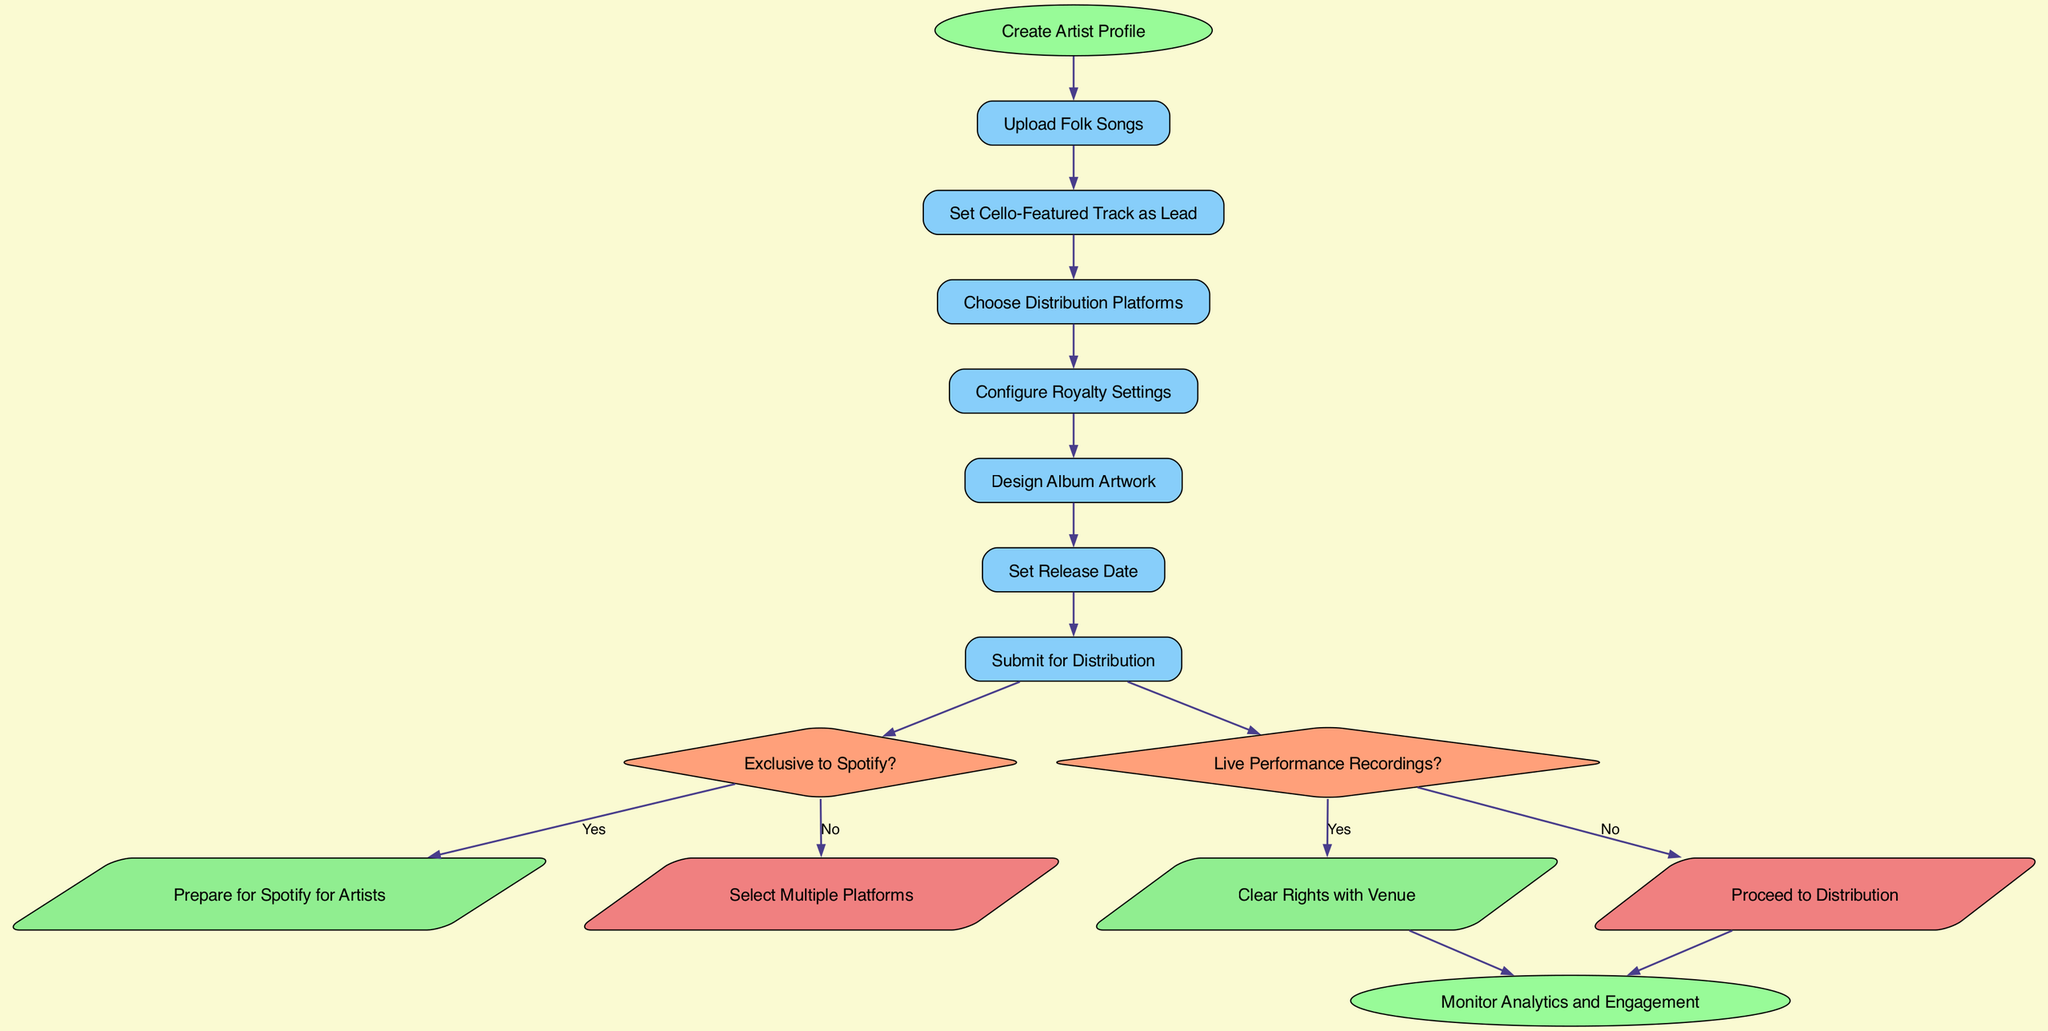What's the starting node of the flowchart? The starting node is indicated at the top of the flowchart and is labeled "Create Artist Profile."
Answer: Create Artist Profile How many nodes are there in total? Count all the nodes, including the start and end nodes. The nodes listed are: Create Artist Profile, Upload Folk Songs, Set Cello-Featured Track as Lead, Choose Distribution Platforms, Configure Royalty Settings, Design Album Artwork, Set Release Date, Submit for Distribution, and Monitor Analytics and Engagement, which totals 10 nodes.
Answer: 10 What are the actions performed after "Submit for Distribution"? After "Submit for Distribution," the flowchart leads to a decision node asking if there are live performance recordings.
Answer: Clear Rights with Venue or Proceed to Distribution What happens if you select "Exclusive to Spotify?" If "Exclusive to Spotify?" is selected as yes, the flowchart indicates the next step is "Prepare for Spotify for Artists."
Answer: Prepare for Spotify for Artists What is the last action taken in the flowchart? The last action taken in the flowchart is indicated by the end node, which states "Monitor Analytics and Engagement."
Answer: Monitor Analytics and Engagement If "Live Performance Recordings" is answered with "Yes," what is the next step? If "Live Performance Recordings?" is answered with "Yes," the flowchart specifies to "Clear Rights with Venue" as the next step.
Answer: Clear Rights with Venue What color is used for the decision nodes? The flowchart uses a light salmon color for the decision nodes.
Answer: Light salmon Which node follows "Choose Distribution Platforms"? The node that follows "Choose Distribution Platforms" is "Configure Royalty Settings."
Answer: Configure Royalty Settings What shape is the end node? The end node is shaped like an ellipse, which is typical for denoting the end of a process in flowcharts.
Answer: Ellipse 